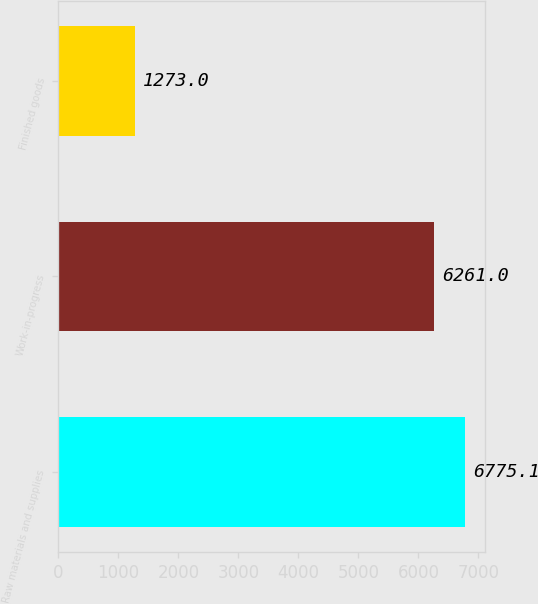Convert chart. <chart><loc_0><loc_0><loc_500><loc_500><bar_chart><fcel>Raw materials and supplies<fcel>Work-in-progress<fcel>Finished goods<nl><fcel>6775.1<fcel>6261<fcel>1273<nl></chart> 